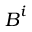<formula> <loc_0><loc_0><loc_500><loc_500>B ^ { i }</formula> 